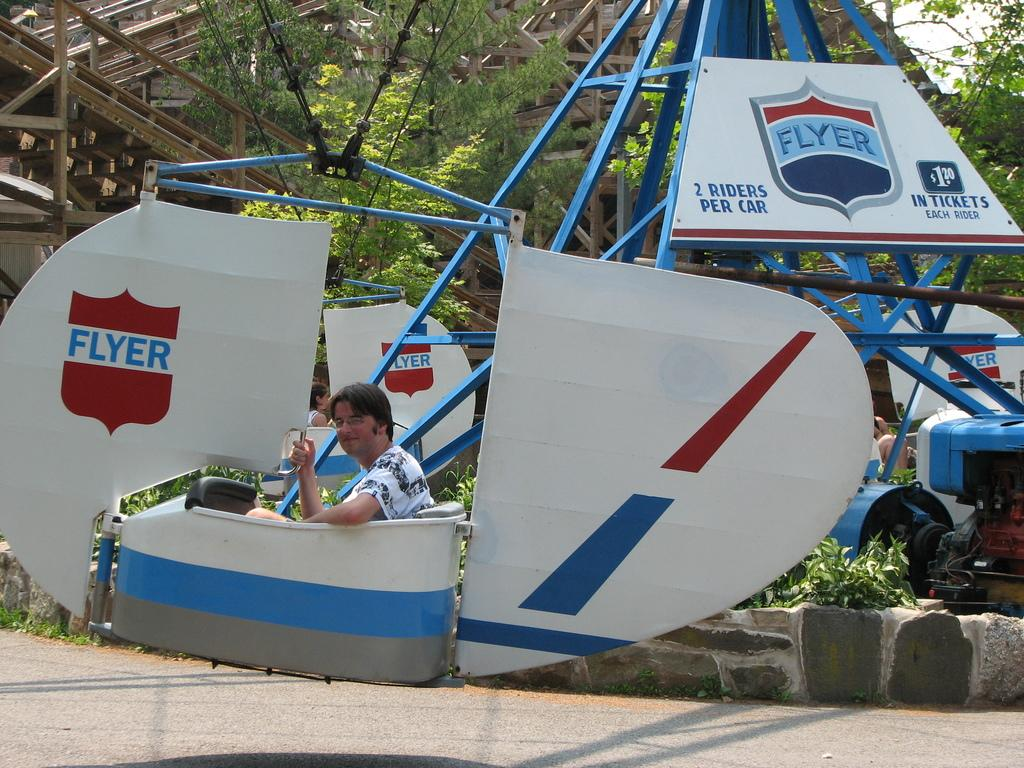<image>
Offer a succinct explanation of the picture presented. A man is riding in an amusement park ride called the Flyer. 